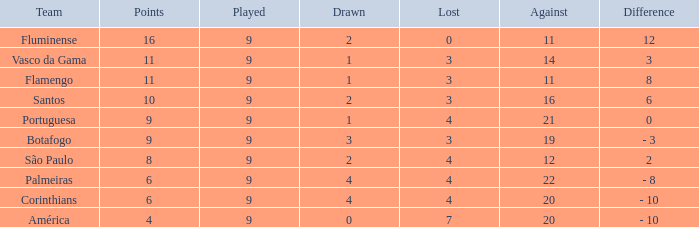Which average Played has a Drawn smaller than 1, and Points larger than 4? None. 